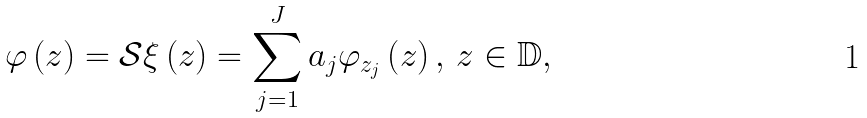Convert formula to latex. <formula><loc_0><loc_0><loc_500><loc_500>\varphi \left ( z \right ) = \mathcal { S } \xi \left ( z \right ) = \sum _ { j = 1 } ^ { J } a _ { j } \varphi _ { z _ { j } } \left ( z \right ) , \, z \in \mathbb { D } ,</formula> 